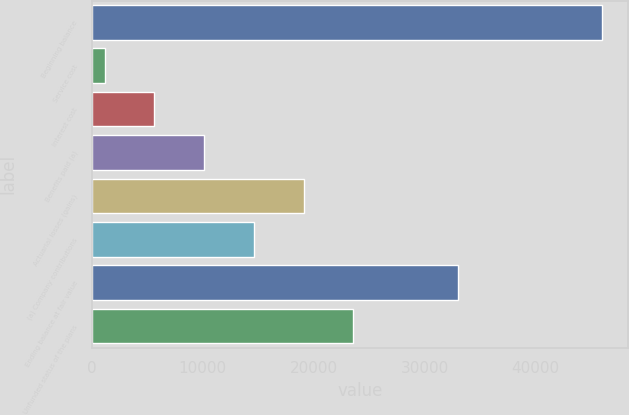Convert chart to OTSL. <chart><loc_0><loc_0><loc_500><loc_500><bar_chart><fcel>Beginning balance<fcel>Service cost<fcel>Interest cost<fcel>Benefits paid (a)<fcel>Actuarial losses (gains)<fcel>(a) Company contributions<fcel>Ending balance at fair value<fcel>Unfunded status of the plans<nl><fcel>46017<fcel>1142<fcel>5629.5<fcel>10117<fcel>19092<fcel>14604.5<fcel>33010<fcel>23579.5<nl></chart> 